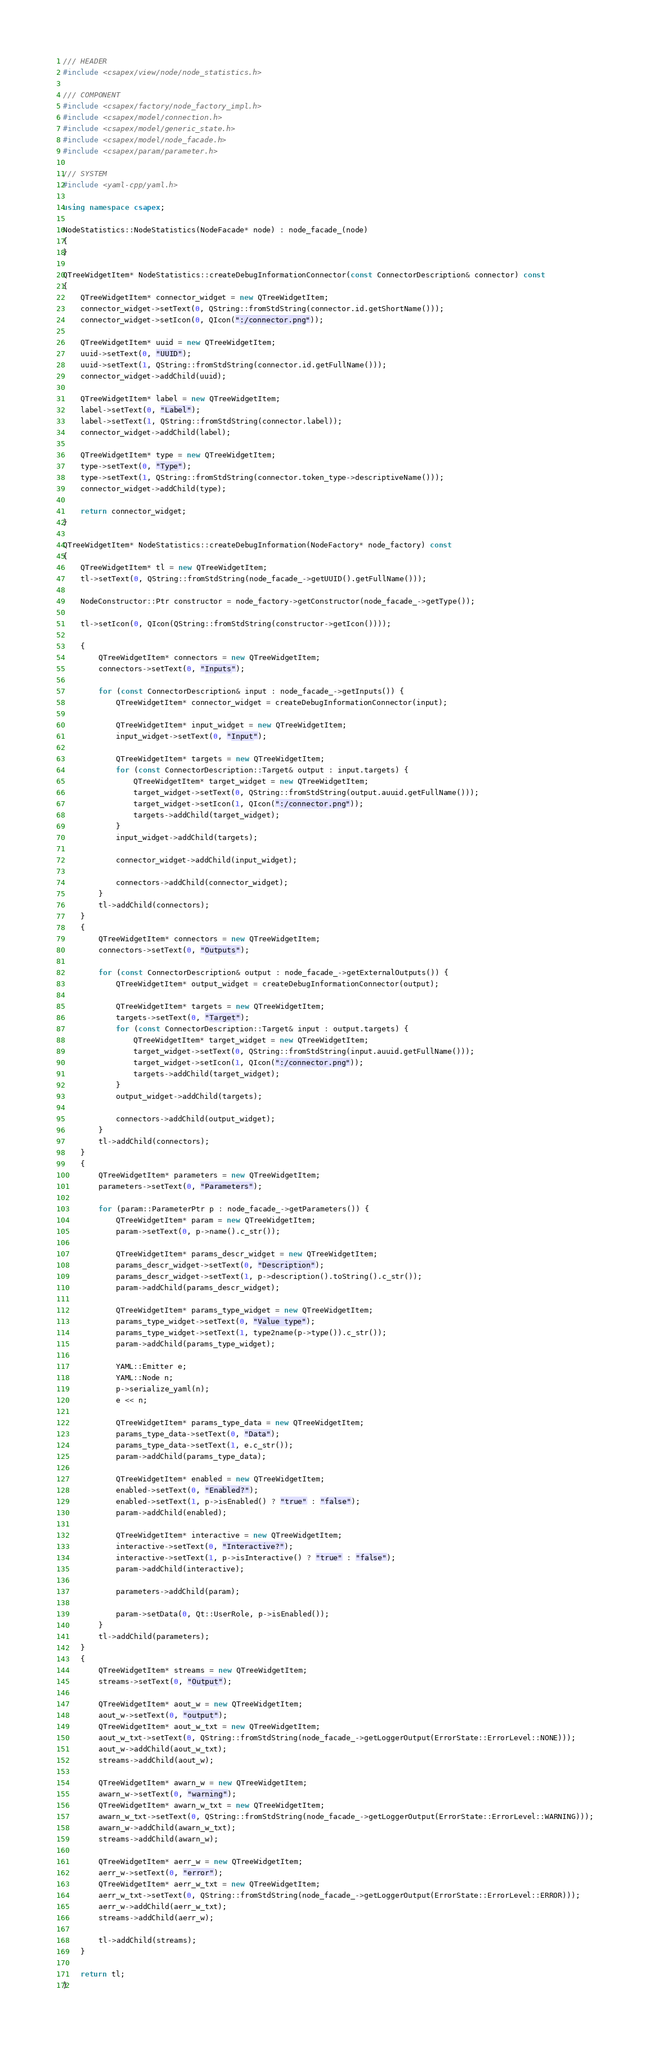<code> <loc_0><loc_0><loc_500><loc_500><_C++_>/// HEADER
#include <csapex/view/node/node_statistics.h>

/// COMPONENT
#include <csapex/factory/node_factory_impl.h>
#include <csapex/model/connection.h>
#include <csapex/model/generic_state.h>
#include <csapex/model/node_facade.h>
#include <csapex/param/parameter.h>

/// SYSTEM
#include <yaml-cpp/yaml.h>

using namespace csapex;

NodeStatistics::NodeStatistics(NodeFacade* node) : node_facade_(node)
{
}

QTreeWidgetItem* NodeStatistics::createDebugInformationConnector(const ConnectorDescription& connector) const
{
    QTreeWidgetItem* connector_widget = new QTreeWidgetItem;
    connector_widget->setText(0, QString::fromStdString(connector.id.getShortName()));
    connector_widget->setIcon(0, QIcon(":/connector.png"));

    QTreeWidgetItem* uuid = new QTreeWidgetItem;
    uuid->setText(0, "UUID");
    uuid->setText(1, QString::fromStdString(connector.id.getFullName()));
    connector_widget->addChild(uuid);

    QTreeWidgetItem* label = new QTreeWidgetItem;
    label->setText(0, "Label");
    label->setText(1, QString::fromStdString(connector.label));
    connector_widget->addChild(label);

    QTreeWidgetItem* type = new QTreeWidgetItem;
    type->setText(0, "Type");
    type->setText(1, QString::fromStdString(connector.token_type->descriptiveName()));
    connector_widget->addChild(type);

    return connector_widget;
}

QTreeWidgetItem* NodeStatistics::createDebugInformation(NodeFactory* node_factory) const
{
    QTreeWidgetItem* tl = new QTreeWidgetItem;
    tl->setText(0, QString::fromStdString(node_facade_->getUUID().getFullName()));

    NodeConstructor::Ptr constructor = node_factory->getConstructor(node_facade_->getType());

    tl->setIcon(0, QIcon(QString::fromStdString(constructor->getIcon())));

    {
        QTreeWidgetItem* connectors = new QTreeWidgetItem;
        connectors->setText(0, "Inputs");

        for (const ConnectorDescription& input : node_facade_->getInputs()) {
            QTreeWidgetItem* connector_widget = createDebugInformationConnector(input);

            QTreeWidgetItem* input_widget = new QTreeWidgetItem;
            input_widget->setText(0, "Input");

            QTreeWidgetItem* targets = new QTreeWidgetItem;
            for (const ConnectorDescription::Target& output : input.targets) {
                QTreeWidgetItem* target_widget = new QTreeWidgetItem;
                target_widget->setText(0, QString::fromStdString(output.auuid.getFullName()));
                target_widget->setIcon(1, QIcon(":/connector.png"));
                targets->addChild(target_widget);
            }
            input_widget->addChild(targets);

            connector_widget->addChild(input_widget);

            connectors->addChild(connector_widget);
        }
        tl->addChild(connectors);
    }
    {
        QTreeWidgetItem* connectors = new QTreeWidgetItem;
        connectors->setText(0, "Outputs");

        for (const ConnectorDescription& output : node_facade_->getExternalOutputs()) {
            QTreeWidgetItem* output_widget = createDebugInformationConnector(output);

            QTreeWidgetItem* targets = new QTreeWidgetItem;
            targets->setText(0, "Target");
            for (const ConnectorDescription::Target& input : output.targets) {
                QTreeWidgetItem* target_widget = new QTreeWidgetItem;
                target_widget->setText(0, QString::fromStdString(input.auuid.getFullName()));
                target_widget->setIcon(1, QIcon(":/connector.png"));
                targets->addChild(target_widget);
            }
            output_widget->addChild(targets);

            connectors->addChild(output_widget);
        }
        tl->addChild(connectors);
    }
    {
        QTreeWidgetItem* parameters = new QTreeWidgetItem;
        parameters->setText(0, "Parameters");

        for (param::ParameterPtr p : node_facade_->getParameters()) {
            QTreeWidgetItem* param = new QTreeWidgetItem;
            param->setText(0, p->name().c_str());

            QTreeWidgetItem* params_descr_widget = new QTreeWidgetItem;
            params_descr_widget->setText(0, "Description");
            params_descr_widget->setText(1, p->description().toString().c_str());
            param->addChild(params_descr_widget);

            QTreeWidgetItem* params_type_widget = new QTreeWidgetItem;
            params_type_widget->setText(0, "Value type");
            params_type_widget->setText(1, type2name(p->type()).c_str());
            param->addChild(params_type_widget);

            YAML::Emitter e;
            YAML::Node n;
            p->serialize_yaml(n);
            e << n;

            QTreeWidgetItem* params_type_data = new QTreeWidgetItem;
            params_type_data->setText(0, "Data");
            params_type_data->setText(1, e.c_str());
            param->addChild(params_type_data);

            QTreeWidgetItem* enabled = new QTreeWidgetItem;
            enabled->setText(0, "Enabled?");
            enabled->setText(1, p->isEnabled() ? "true" : "false");
            param->addChild(enabled);

            QTreeWidgetItem* interactive = new QTreeWidgetItem;
            interactive->setText(0, "Interactive?");
            interactive->setText(1, p->isInteractive() ? "true" : "false");
            param->addChild(interactive);

            parameters->addChild(param);

            param->setData(0, Qt::UserRole, p->isEnabled());
        }
        tl->addChild(parameters);
    }
    {
        QTreeWidgetItem* streams = new QTreeWidgetItem;
        streams->setText(0, "Output");

        QTreeWidgetItem* aout_w = new QTreeWidgetItem;
        aout_w->setText(0, "output");
        QTreeWidgetItem* aout_w_txt = new QTreeWidgetItem;
        aout_w_txt->setText(0, QString::fromStdString(node_facade_->getLoggerOutput(ErrorState::ErrorLevel::NONE)));
        aout_w->addChild(aout_w_txt);
        streams->addChild(aout_w);

        QTreeWidgetItem* awarn_w = new QTreeWidgetItem;
        awarn_w->setText(0, "warning");
        QTreeWidgetItem* awarn_w_txt = new QTreeWidgetItem;
        awarn_w_txt->setText(0, QString::fromStdString(node_facade_->getLoggerOutput(ErrorState::ErrorLevel::WARNING)));
        awarn_w->addChild(awarn_w_txt);
        streams->addChild(awarn_w);

        QTreeWidgetItem* aerr_w = new QTreeWidgetItem;
        aerr_w->setText(0, "error");
        QTreeWidgetItem* aerr_w_txt = new QTreeWidgetItem;
        aerr_w_txt->setText(0, QString::fromStdString(node_facade_->getLoggerOutput(ErrorState::ErrorLevel::ERROR)));
        aerr_w->addChild(aerr_w_txt);
        streams->addChild(aerr_w);

        tl->addChild(streams);
    }

    return tl;
}
</code> 